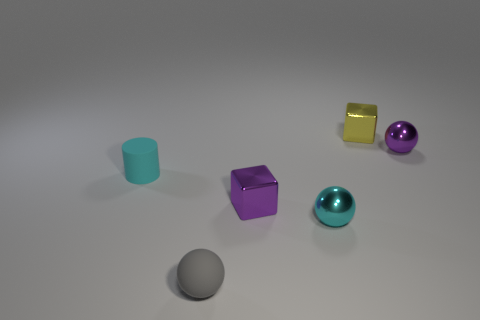Subtract all tiny rubber spheres. How many spheres are left? 2 Add 3 cyan metallic balls. How many objects exist? 9 Subtract all cubes. How many objects are left? 4 Subtract 2 balls. How many balls are left? 1 Add 2 gray matte spheres. How many gray matte spheres exist? 3 Subtract all cyan spheres. How many spheres are left? 2 Subtract 1 purple cubes. How many objects are left? 5 Subtract all green blocks. Subtract all cyan cylinders. How many blocks are left? 2 Subtract all purple cylinders. How many blue spheres are left? 0 Subtract all large matte things. Subtract all small cyan spheres. How many objects are left? 5 